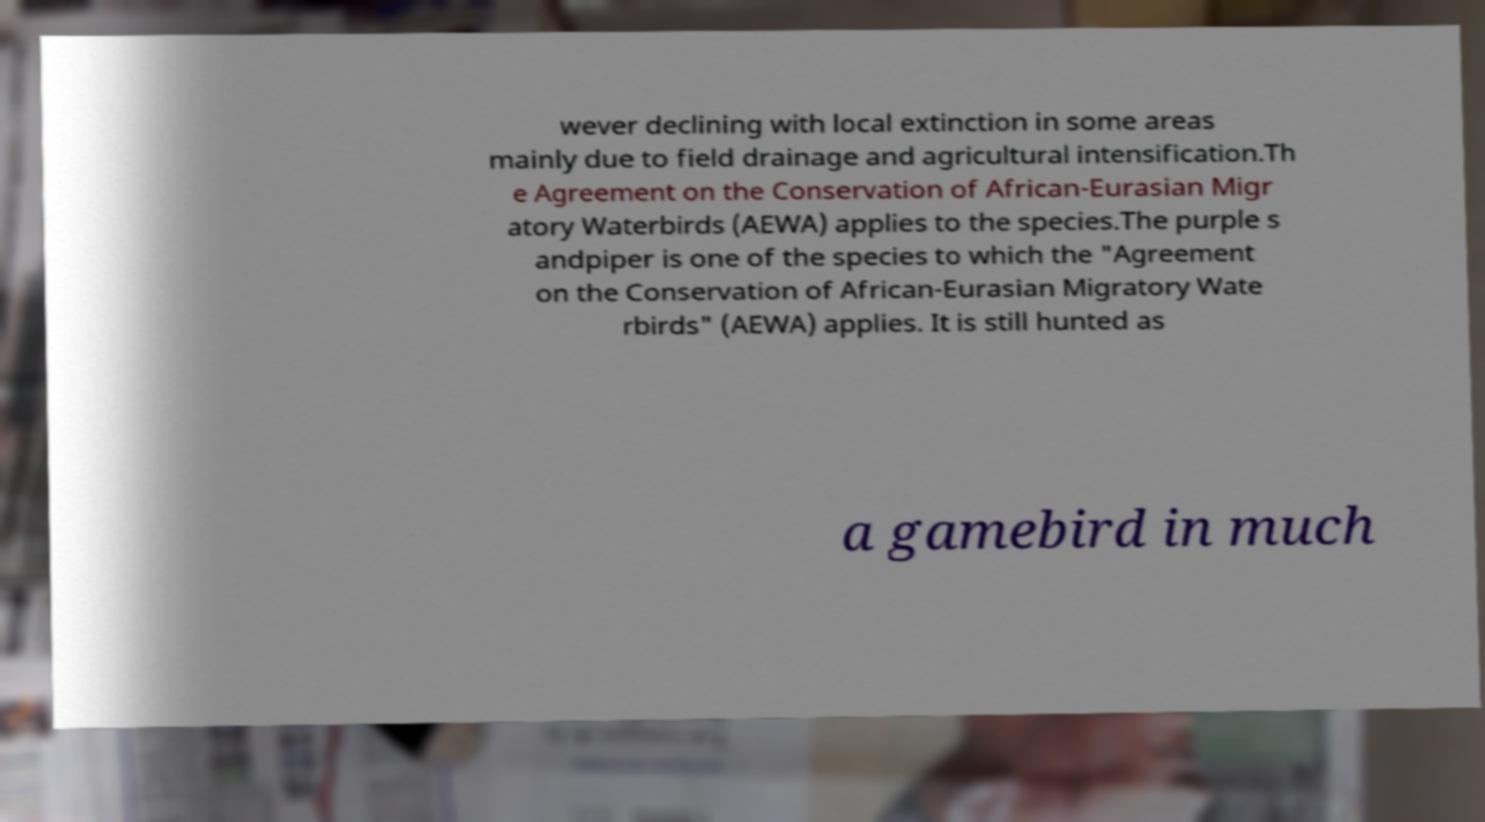What messages or text are displayed in this image? I need them in a readable, typed format. wever declining with local extinction in some areas mainly due to field drainage and agricultural intensification.Th e Agreement on the Conservation of African-Eurasian Migr atory Waterbirds (AEWA) applies to the species.The purple s andpiper is one of the species to which the "Agreement on the Conservation of African-Eurasian Migratory Wate rbirds" (AEWA) applies. It is still hunted as a gamebird in much 